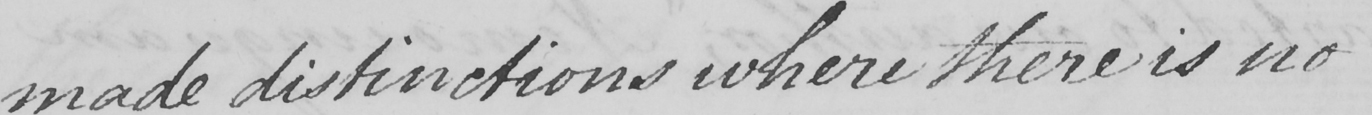What does this handwritten line say? made distinctions where there is no 